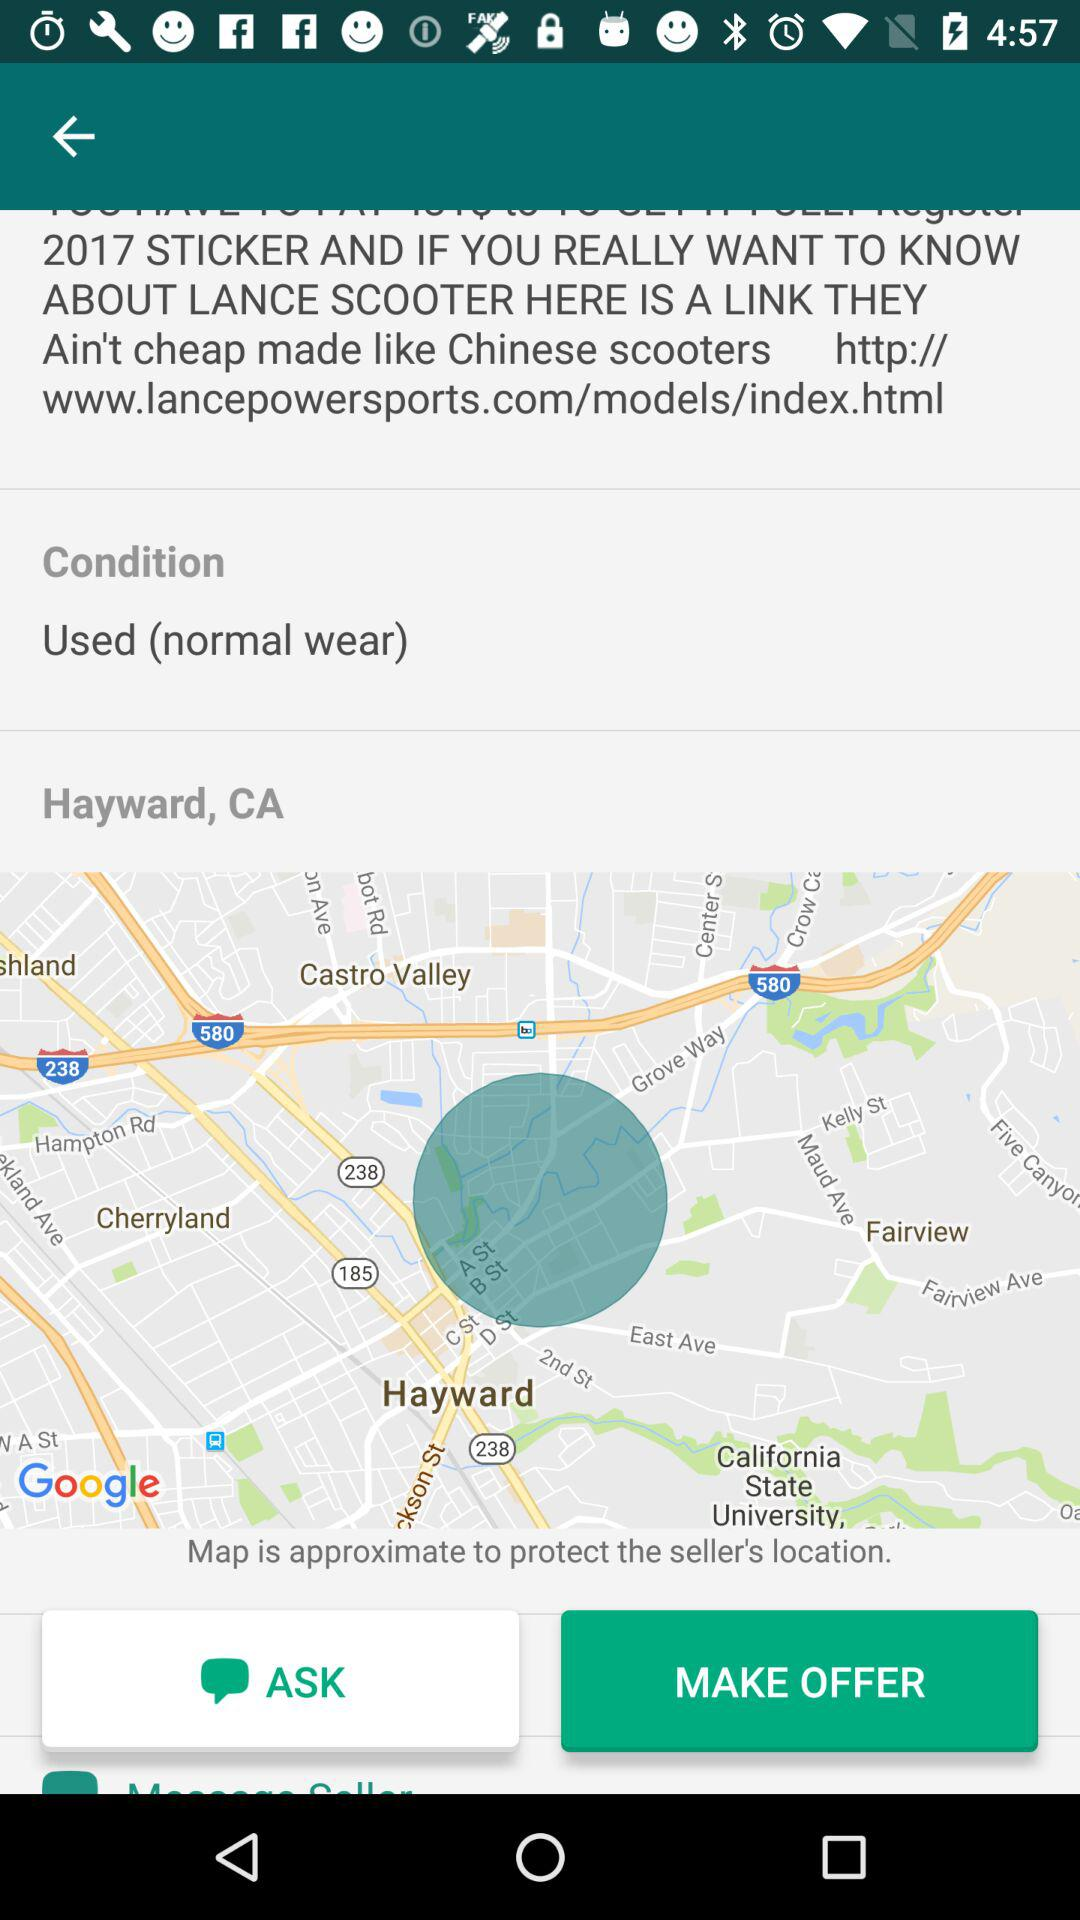What is the location? The location is Hayward, CA. 